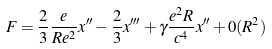Convert formula to latex. <formula><loc_0><loc_0><loc_500><loc_500>F = \frac { 2 } { 3 } \frac { e } { R e ^ { 2 } } x ^ { \prime \prime } - \frac { 2 } { 3 } x ^ { \prime \prime \prime } + \gamma \frac { e ^ { 2 } R } { c ^ { 4 } } x ^ { \prime \prime } + 0 ( R ^ { 2 } )</formula> 